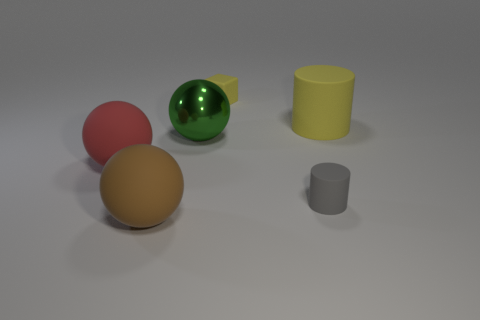Subtract all red balls. How many balls are left? 2 Add 1 brown cylinders. How many objects exist? 7 Subtract all gray cylinders. How many cylinders are left? 1 Subtract 1 spheres. How many spheres are left? 2 Add 6 large gray rubber objects. How many large gray rubber objects exist? 6 Subtract 0 cyan cubes. How many objects are left? 6 Subtract all cylinders. How many objects are left? 4 Subtract all cyan balls. Subtract all gray cylinders. How many balls are left? 3 Subtract all cyan cubes. How many green cylinders are left? 0 Subtract all large metallic spheres. Subtract all rubber spheres. How many objects are left? 3 